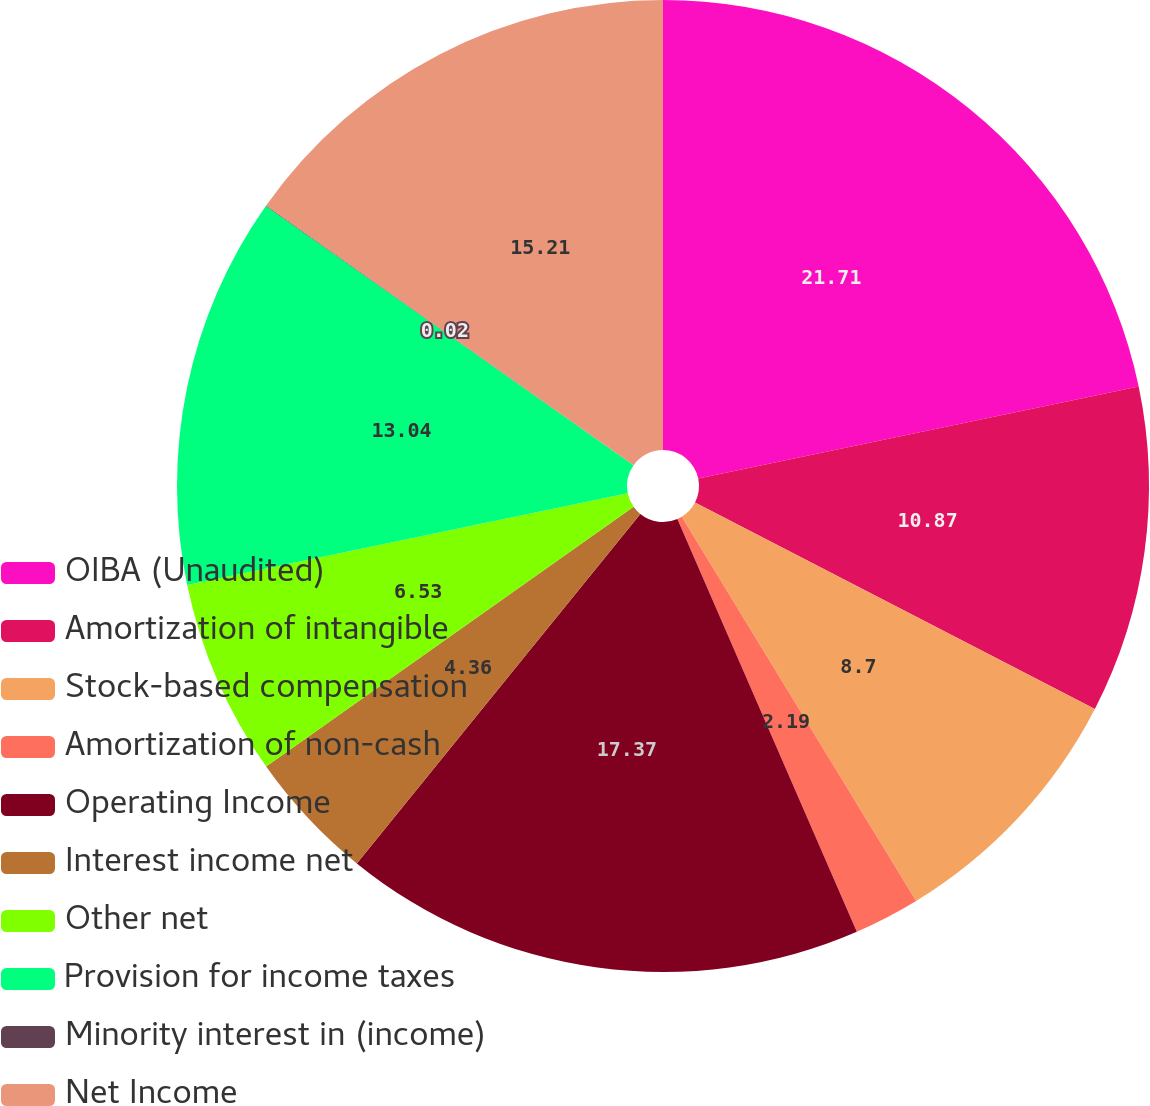Convert chart. <chart><loc_0><loc_0><loc_500><loc_500><pie_chart><fcel>OIBA (Unaudited)<fcel>Amortization of intangible<fcel>Stock-based compensation<fcel>Amortization of non-cash<fcel>Operating Income<fcel>Interest income net<fcel>Other net<fcel>Provision for income taxes<fcel>Minority interest in (income)<fcel>Net Income<nl><fcel>21.72%<fcel>10.87%<fcel>8.7%<fcel>2.19%<fcel>17.38%<fcel>4.36%<fcel>6.53%<fcel>13.04%<fcel>0.02%<fcel>15.21%<nl></chart> 